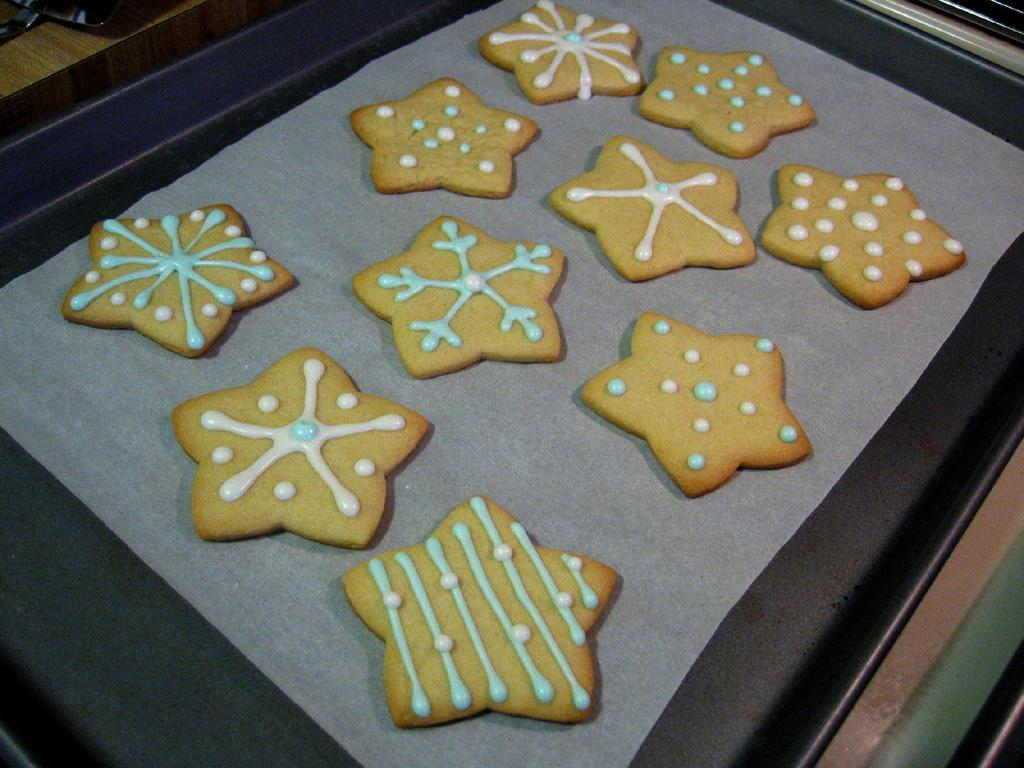What type of food is visible in the image? There are cookies with cream in the image. How are the cookies arranged or presented? The cookies are placed on a paper. What is the paper resting on? The paper is on a black tray. What month is depicted in the image? There is no month depicted in the image; it only shows cookies with cream on a paper and a black tray. 